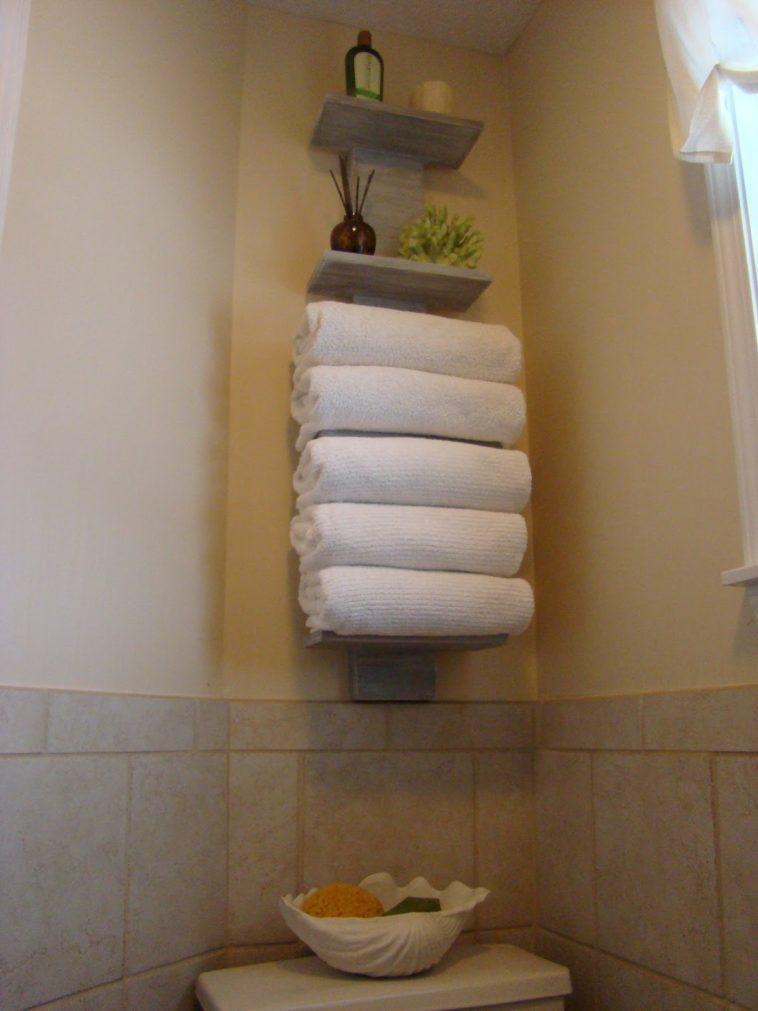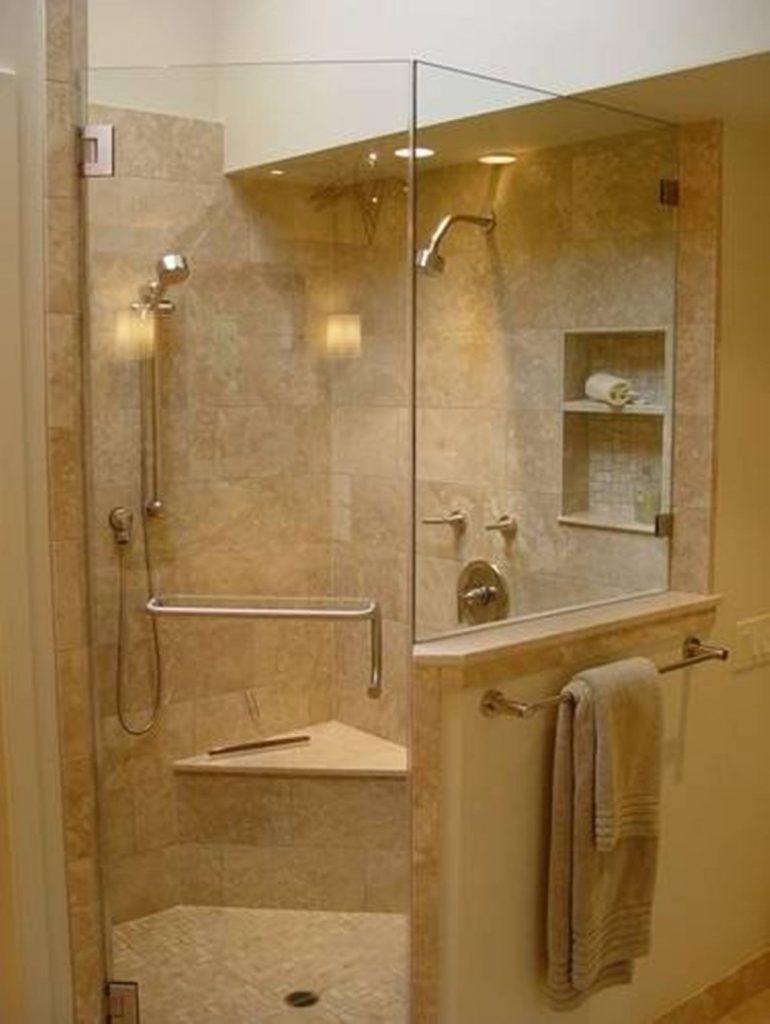The first image is the image on the left, the second image is the image on the right. For the images shown, is this caption "There is a toilet in the image on the left" true? Answer yes or no. No. 